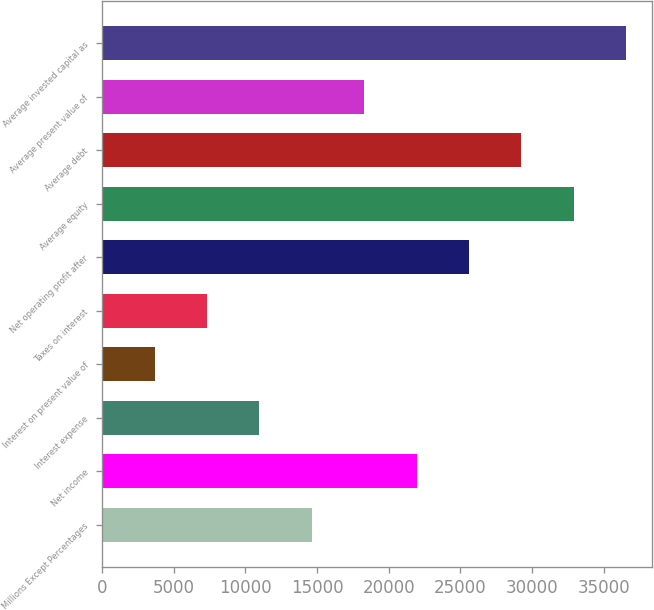Convert chart to OTSL. <chart><loc_0><loc_0><loc_500><loc_500><bar_chart><fcel>Millions Except Percentages<fcel>Net income<fcel>Interest expense<fcel>Interest on present value of<fcel>Taxes on interest<fcel>Net operating profit after<fcel>Average equity<fcel>Average debt<fcel>Average present value of<fcel>Average invested capital as<nl><fcel>14635.4<fcel>21945.9<fcel>10980.1<fcel>3669.57<fcel>7324.84<fcel>25601.2<fcel>32911.7<fcel>29256.5<fcel>18290.7<fcel>36567<nl></chart> 